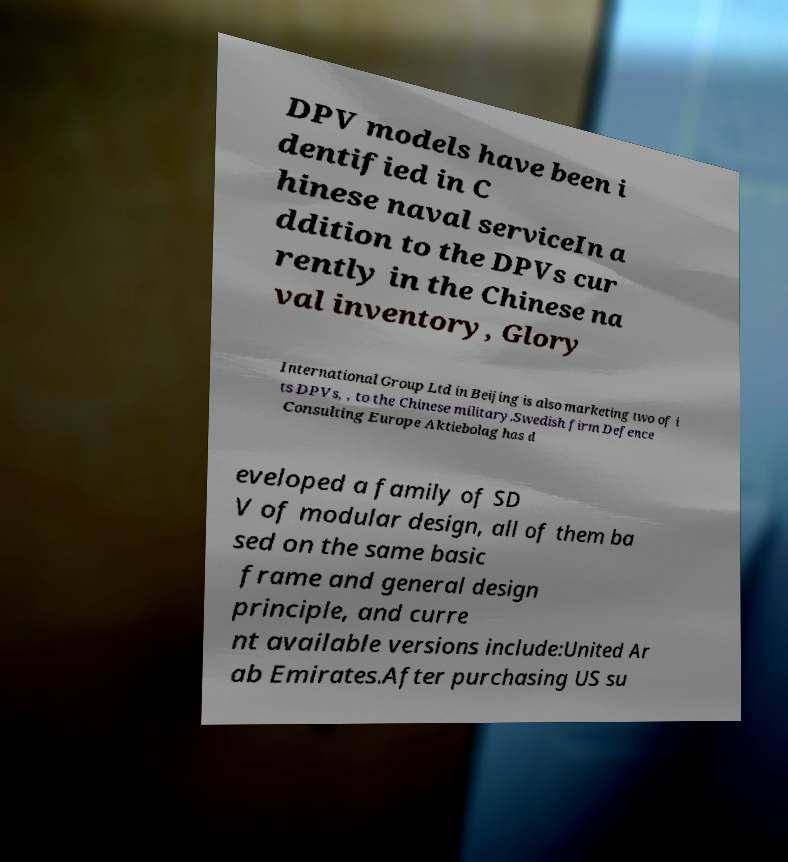Please read and relay the text visible in this image. What does it say? DPV models have been i dentified in C hinese naval serviceIn a ddition to the DPVs cur rently in the Chinese na val inventory, Glory International Group Ltd in Beijing is also marketing two of i ts DPVs, , to the Chinese military.Swedish firm Defence Consulting Europe Aktiebolag has d eveloped a family of SD V of modular design, all of them ba sed on the same basic frame and general design principle, and curre nt available versions include:United Ar ab Emirates.After purchasing US su 